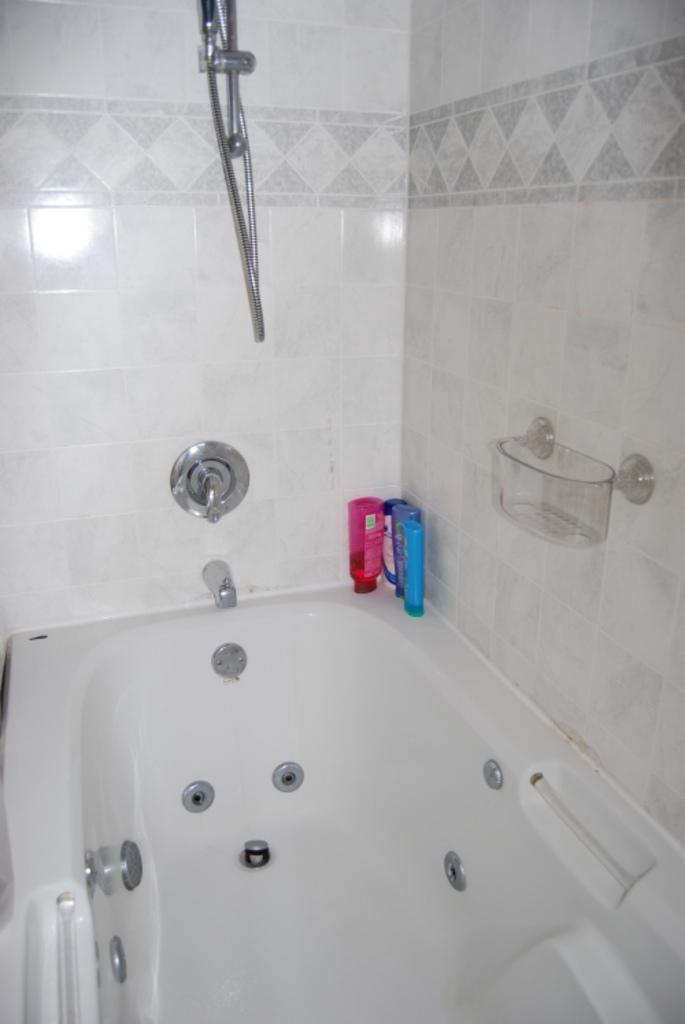What is the main object in the image? There is a bathtub in the image. What can be seen near the bathtub? There are bottles and a soap stand visible in the image. What type of shower is present in the image? There is a hand shower in the image. What is the color of the tiles in the image? The tiles in the image are white. Can you see any toads or vegetables in the image? No, there are no toads or vegetables present in the image. 